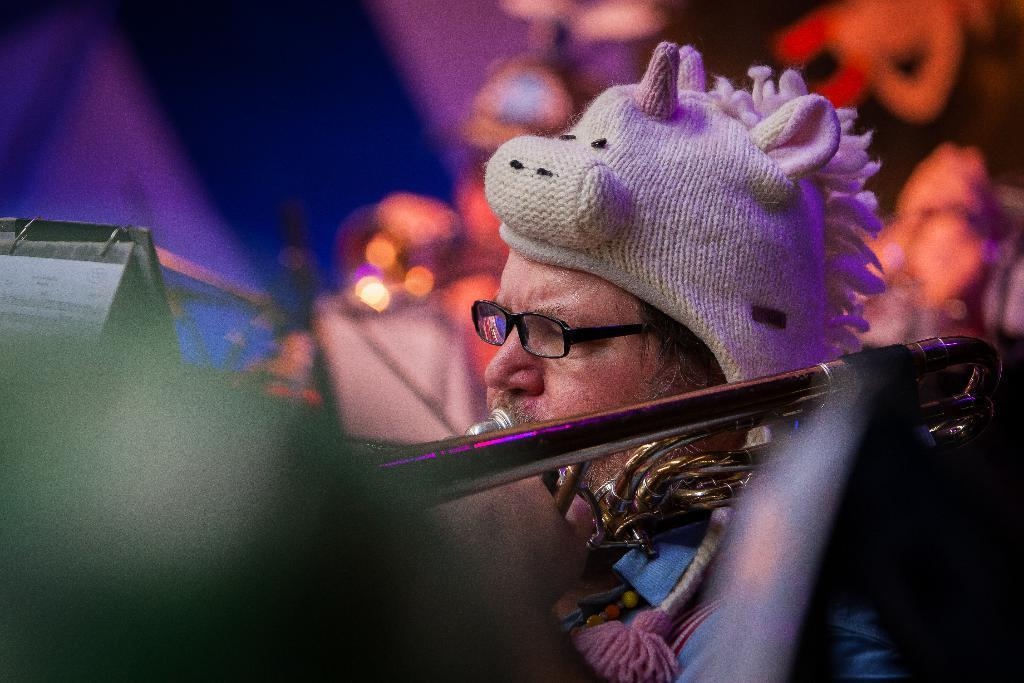What is the man in the image doing? The man is playing a trumpet in the image. What is the man wearing on his head? The man is wearing a cap on his head. What is the man wearing on his face? The man is wearing spectacles on his face. What type of paper can be seen in the image? There is no paper present in the image; it features a man playing a trumpet while wearing a cap and spectacles. 